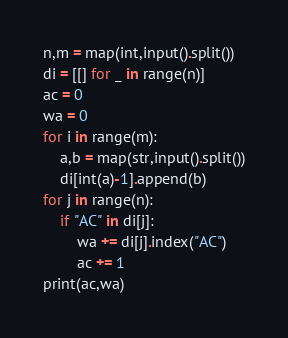Convert code to text. <code><loc_0><loc_0><loc_500><loc_500><_Python_>n,m = map(int,input().split())
di = [[] for _ in range(n)]
ac = 0
wa = 0
for i in range(m):
    a,b = map(str,input().split())
    di[int(a)-1].append(b)
for j in range(n):
    if "AC" in di[j]:
        wa += di[j].index("AC")
        ac += 1
print(ac,wa)</code> 